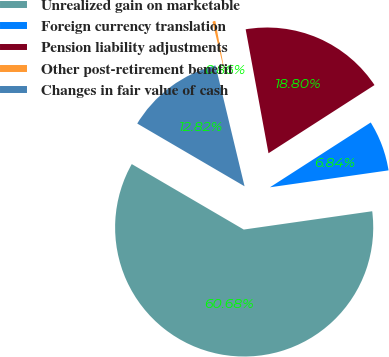<chart> <loc_0><loc_0><loc_500><loc_500><pie_chart><fcel>Unrealized gain on marketable<fcel>Foreign currency translation<fcel>Pension liability adjustments<fcel>Other post-retirement benefit<fcel>Changes in fair value of cash<nl><fcel>60.67%<fcel>6.84%<fcel>18.8%<fcel>0.86%<fcel>12.82%<nl></chart> 